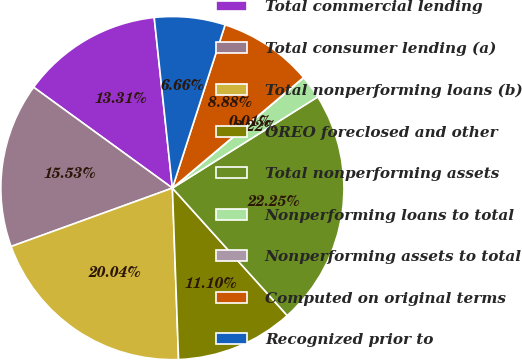Convert chart. <chart><loc_0><loc_0><loc_500><loc_500><pie_chart><fcel>Total commercial lending<fcel>Total consumer lending (a)<fcel>Total nonperforming loans (b)<fcel>OREO foreclosed and other<fcel>Total nonperforming assets<fcel>Nonperforming loans to total<fcel>Nonperforming assets to total<fcel>Computed on original terms<fcel>Recognized prior to<nl><fcel>13.31%<fcel>15.53%<fcel>20.04%<fcel>11.1%<fcel>22.25%<fcel>2.22%<fcel>0.01%<fcel>8.88%<fcel>6.66%<nl></chart> 